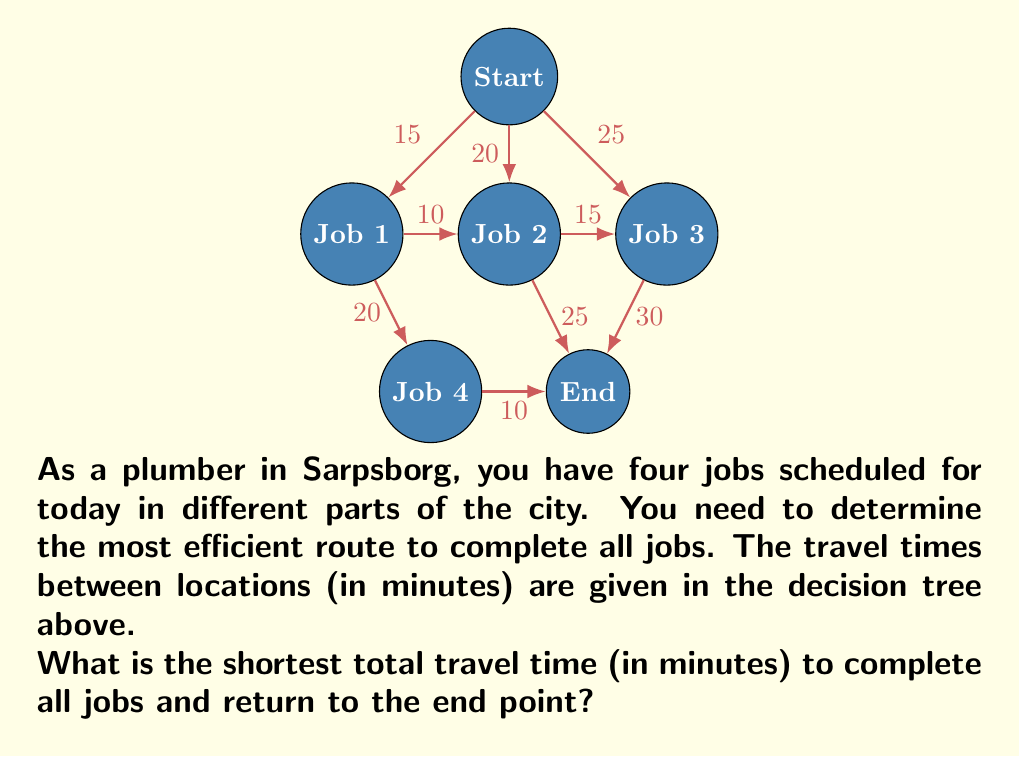Show me your answer to this math problem. To solve this problem, we need to consider all possible routes and calculate their total travel times. We'll use a decision tree approach to find the shortest path.

1. Start by listing all possible routes:
   - Start → Job 1 → Job 2 → Job 3 → Job 4 → End
   - Start → Job 1 → Job 2 → Job 4 → Job 3 → End
   - Start → Job 1 → Job 3 → Job 2 → Job 4 → End
   - Start → Job 1 → Job 4 → Job 2 → Job 3 → End
   - Start → Job 2 → Job 1 → Job 3 → Job 4 → End
   - Start → Job 2 → Job 1 → Job 4 → Job 3 → End
   - Start → Job 2 → Job 3 → Job 1 → Job 4 → End
   - Start → Job 3 → Job 1 → Job 2 → Job 4 → End
   - Start → Job 3 → Job 2 → Job 1 → Job 4 → End

2. Calculate the travel time for each route:
   - Route 1: 15 + 10 + 15 + 20 + 10 = 70 minutes
   - Route 2: 15 + 10 + 25 + 30 = 80 minutes
   - Route 3: 15 + 25 + 15 + 20 + 10 = 85 minutes
   - Route 4: 15 + 20 + 25 + 30 = 90 minutes
   - Route 5: 20 + 10 + 25 + 20 + 10 = 85 minutes
   - Route 6: 20 + 10 + 20 + 30 = 80 minutes
   - Route 7: 20 + 15 + 10 + 20 + 10 = 75 minutes
   - Route 8: 25 + 10 + 10 + 25 + 10 = 80 minutes
   - Route 9: 25 + 15 + 10 + 20 + 10 = 80 minutes

3. Identify the shortest route:
   The shortest route is Route 1, with a total travel time of 70 minutes.

4. Verify the route:
   Start → Job 1 (15 min) → Job 2 (10 min) → Job 3 (15 min) → Job 4 (20 min) → End (10 min)

Therefore, the shortest total travel time to complete all jobs and return to the end point is 70 minutes.
Answer: 70 minutes 